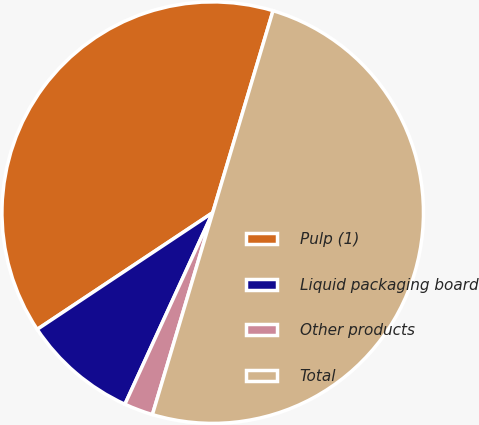Convert chart. <chart><loc_0><loc_0><loc_500><loc_500><pie_chart><fcel>Pulp (1)<fcel>Liquid packaging board<fcel>Other products<fcel>Total<nl><fcel>38.96%<fcel>8.82%<fcel>2.22%<fcel>50.0%<nl></chart> 